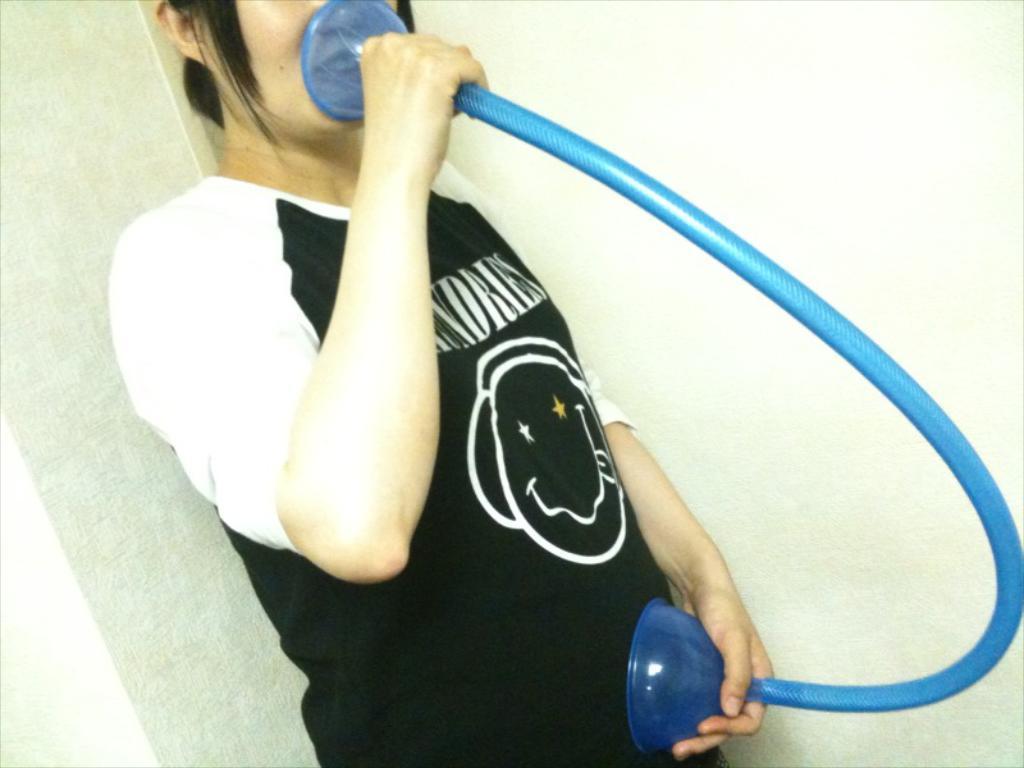Could you give a brief overview of what you see in this image? In the image we can see a person standing, wearing clothes and holding a pipe in hands, this is a wall. 